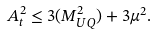<formula> <loc_0><loc_0><loc_500><loc_500>A _ { t } ^ { 2 } \leq 3 ( M _ { U Q } ^ { 2 } ) + 3 \mu ^ { 2 } .</formula> 